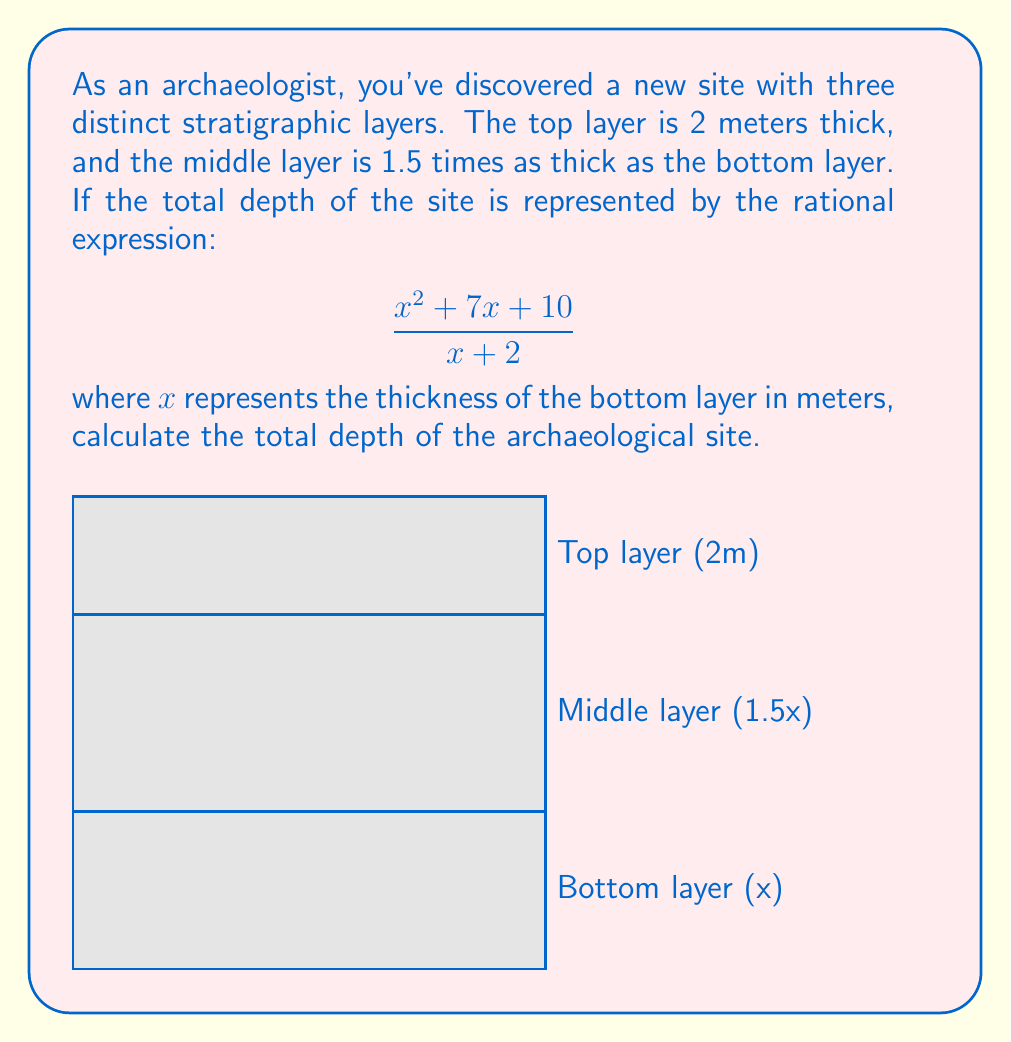Can you solve this math problem? Let's approach this step-by-step:

1) First, let's express the total depth in terms of $x$:
   - Bottom layer: $x$
   - Middle layer: $1.5x$
   - Top layer: $2$
   Total depth = $x + 1.5x + 2 = 2.5x + 2$

2) We're given that the total depth is represented by $\frac{x^2 + 7x + 10}{x + 2}$

3) Therefore, we can set up the equation:

   $$2.5x + 2 = \frac{x^2 + 7x + 10}{x + 2}$$

4) Multiply both sides by $(x + 2)$:

   $$(2.5x + 2)(x + 2) = x^2 + 7x + 10$$

5) Expand the left side:

   $$2.5x^2 + 5x + 2x + 4 = x^2 + 7x + 10$$
   $$2.5x^2 + 7x + 4 = x^2 + 7x + 10$$

6) Subtract $x^2 + 7x$ from both sides:

   $$1.5x^2 + 4 = 10$$

7) Subtract 4 from both sides:

   $$1.5x^2 = 6$$

8) Divide by 1.5:

   $$x^2 = 4$$

9) Take the square root of both sides:

   $$x = 2$$ (we take the positive root as depth cannot be negative)

10) Now that we know $x = 2$, we can calculate the total depth:
    Total depth = $2.5x + 2 = 2.5(2) + 2 = 5 + 2 = 7$

Therefore, the total depth of the archaeological site is 7 meters.
Answer: 7 meters 